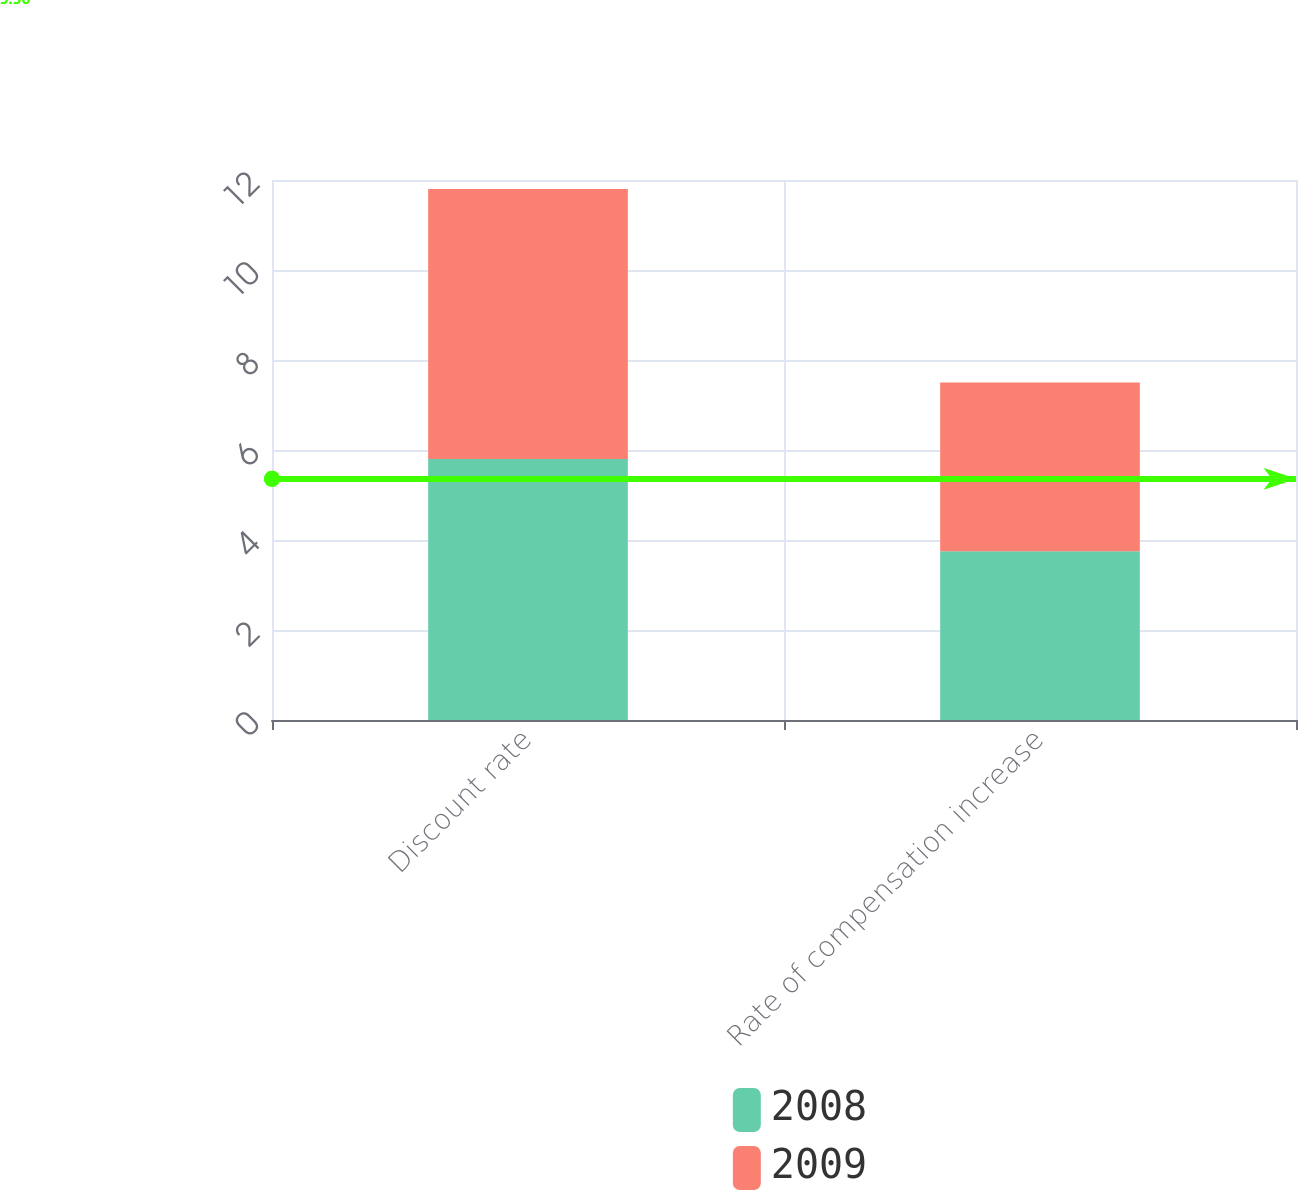Convert chart. <chart><loc_0><loc_0><loc_500><loc_500><stacked_bar_chart><ecel><fcel>Discount rate<fcel>Rate of compensation increase<nl><fcel>2008<fcel>5.8<fcel>3.75<nl><fcel>2009<fcel>6<fcel>3.75<nl></chart> 